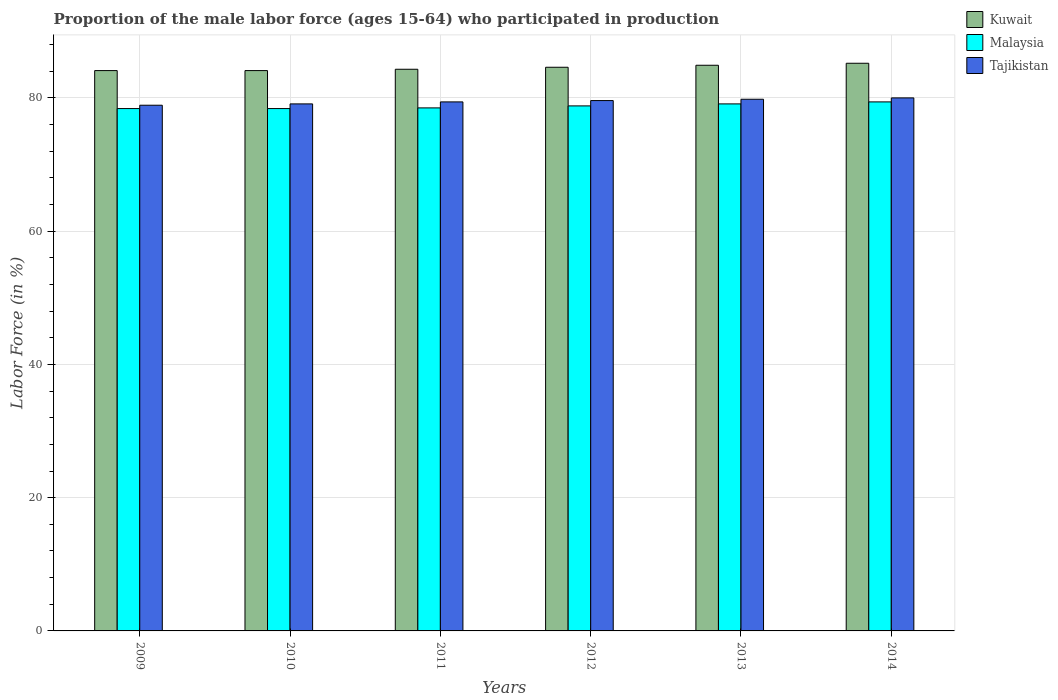How many bars are there on the 6th tick from the left?
Give a very brief answer. 3. In how many cases, is the number of bars for a given year not equal to the number of legend labels?
Your answer should be very brief. 0. What is the proportion of the male labor force who participated in production in Tajikistan in 2010?
Make the answer very short. 79.1. Across all years, what is the maximum proportion of the male labor force who participated in production in Tajikistan?
Give a very brief answer. 80. Across all years, what is the minimum proportion of the male labor force who participated in production in Kuwait?
Ensure brevity in your answer.  84.1. In which year was the proportion of the male labor force who participated in production in Kuwait maximum?
Provide a short and direct response. 2014. In which year was the proportion of the male labor force who participated in production in Kuwait minimum?
Provide a short and direct response. 2009. What is the total proportion of the male labor force who participated in production in Malaysia in the graph?
Your answer should be very brief. 472.6. What is the difference between the proportion of the male labor force who participated in production in Malaysia in 2013 and that in 2014?
Make the answer very short. -0.3. What is the difference between the proportion of the male labor force who participated in production in Kuwait in 2012 and the proportion of the male labor force who participated in production in Tajikistan in 2013?
Make the answer very short. 4.8. What is the average proportion of the male labor force who participated in production in Malaysia per year?
Keep it short and to the point. 78.77. In the year 2012, what is the difference between the proportion of the male labor force who participated in production in Malaysia and proportion of the male labor force who participated in production in Kuwait?
Your response must be concise. -5.8. What is the ratio of the proportion of the male labor force who participated in production in Tajikistan in 2010 to that in 2014?
Make the answer very short. 0.99. Is the proportion of the male labor force who participated in production in Malaysia in 2009 less than that in 2012?
Your answer should be compact. Yes. What is the difference between the highest and the second highest proportion of the male labor force who participated in production in Tajikistan?
Provide a short and direct response. 0.2. What is the difference between the highest and the lowest proportion of the male labor force who participated in production in Kuwait?
Your answer should be very brief. 1.1. In how many years, is the proportion of the male labor force who participated in production in Tajikistan greater than the average proportion of the male labor force who participated in production in Tajikistan taken over all years?
Make the answer very short. 3. What does the 1st bar from the left in 2009 represents?
Ensure brevity in your answer.  Kuwait. What does the 2nd bar from the right in 2011 represents?
Provide a short and direct response. Malaysia. How many bars are there?
Your answer should be very brief. 18. How many years are there in the graph?
Provide a succinct answer. 6. What is the difference between two consecutive major ticks on the Y-axis?
Ensure brevity in your answer.  20. Does the graph contain any zero values?
Ensure brevity in your answer.  No. Does the graph contain grids?
Make the answer very short. Yes. Where does the legend appear in the graph?
Provide a succinct answer. Top right. How many legend labels are there?
Your response must be concise. 3. What is the title of the graph?
Offer a terse response. Proportion of the male labor force (ages 15-64) who participated in production. What is the Labor Force (in %) in Kuwait in 2009?
Give a very brief answer. 84.1. What is the Labor Force (in %) in Malaysia in 2009?
Provide a succinct answer. 78.4. What is the Labor Force (in %) in Tajikistan in 2009?
Provide a short and direct response. 78.9. What is the Labor Force (in %) in Kuwait in 2010?
Give a very brief answer. 84.1. What is the Labor Force (in %) in Malaysia in 2010?
Offer a terse response. 78.4. What is the Labor Force (in %) of Tajikistan in 2010?
Give a very brief answer. 79.1. What is the Labor Force (in %) in Kuwait in 2011?
Keep it short and to the point. 84.3. What is the Labor Force (in %) of Malaysia in 2011?
Give a very brief answer. 78.5. What is the Labor Force (in %) in Tajikistan in 2011?
Give a very brief answer. 79.4. What is the Labor Force (in %) in Kuwait in 2012?
Your answer should be very brief. 84.6. What is the Labor Force (in %) of Malaysia in 2012?
Your response must be concise. 78.8. What is the Labor Force (in %) of Tajikistan in 2012?
Your answer should be compact. 79.6. What is the Labor Force (in %) of Kuwait in 2013?
Keep it short and to the point. 84.9. What is the Labor Force (in %) of Malaysia in 2013?
Keep it short and to the point. 79.1. What is the Labor Force (in %) of Tajikistan in 2013?
Your answer should be very brief. 79.8. What is the Labor Force (in %) in Kuwait in 2014?
Your answer should be compact. 85.2. What is the Labor Force (in %) in Malaysia in 2014?
Provide a succinct answer. 79.4. What is the Labor Force (in %) in Tajikistan in 2014?
Provide a short and direct response. 80. Across all years, what is the maximum Labor Force (in %) in Kuwait?
Your answer should be compact. 85.2. Across all years, what is the maximum Labor Force (in %) of Malaysia?
Your answer should be very brief. 79.4. Across all years, what is the minimum Labor Force (in %) in Kuwait?
Provide a short and direct response. 84.1. Across all years, what is the minimum Labor Force (in %) of Malaysia?
Your answer should be very brief. 78.4. Across all years, what is the minimum Labor Force (in %) of Tajikistan?
Keep it short and to the point. 78.9. What is the total Labor Force (in %) in Kuwait in the graph?
Your answer should be very brief. 507.2. What is the total Labor Force (in %) in Malaysia in the graph?
Offer a very short reply. 472.6. What is the total Labor Force (in %) in Tajikistan in the graph?
Provide a short and direct response. 476.8. What is the difference between the Labor Force (in %) in Malaysia in 2009 and that in 2010?
Provide a succinct answer. 0. What is the difference between the Labor Force (in %) of Tajikistan in 2009 and that in 2010?
Your answer should be compact. -0.2. What is the difference between the Labor Force (in %) of Tajikistan in 2009 and that in 2011?
Ensure brevity in your answer.  -0.5. What is the difference between the Labor Force (in %) of Kuwait in 2009 and that in 2012?
Offer a terse response. -0.5. What is the difference between the Labor Force (in %) in Tajikistan in 2009 and that in 2012?
Offer a very short reply. -0.7. What is the difference between the Labor Force (in %) of Kuwait in 2009 and that in 2013?
Offer a very short reply. -0.8. What is the difference between the Labor Force (in %) of Malaysia in 2009 and that in 2013?
Keep it short and to the point. -0.7. What is the difference between the Labor Force (in %) in Malaysia in 2009 and that in 2014?
Provide a succinct answer. -1. What is the difference between the Labor Force (in %) in Malaysia in 2010 and that in 2011?
Ensure brevity in your answer.  -0.1. What is the difference between the Labor Force (in %) of Tajikistan in 2010 and that in 2011?
Ensure brevity in your answer.  -0.3. What is the difference between the Labor Force (in %) of Kuwait in 2010 and that in 2012?
Keep it short and to the point. -0.5. What is the difference between the Labor Force (in %) in Tajikistan in 2010 and that in 2012?
Keep it short and to the point. -0.5. What is the difference between the Labor Force (in %) in Kuwait in 2010 and that in 2013?
Provide a succinct answer. -0.8. What is the difference between the Labor Force (in %) in Malaysia in 2010 and that in 2013?
Keep it short and to the point. -0.7. What is the difference between the Labor Force (in %) of Tajikistan in 2010 and that in 2013?
Offer a terse response. -0.7. What is the difference between the Labor Force (in %) in Kuwait in 2010 and that in 2014?
Ensure brevity in your answer.  -1.1. What is the difference between the Labor Force (in %) in Malaysia in 2010 and that in 2014?
Your answer should be very brief. -1. What is the difference between the Labor Force (in %) in Kuwait in 2011 and that in 2012?
Ensure brevity in your answer.  -0.3. What is the difference between the Labor Force (in %) of Tajikistan in 2011 and that in 2012?
Give a very brief answer. -0.2. What is the difference between the Labor Force (in %) in Kuwait in 2011 and that in 2013?
Make the answer very short. -0.6. What is the difference between the Labor Force (in %) of Malaysia in 2011 and that in 2013?
Your answer should be compact. -0.6. What is the difference between the Labor Force (in %) of Tajikistan in 2011 and that in 2013?
Make the answer very short. -0.4. What is the difference between the Labor Force (in %) of Kuwait in 2011 and that in 2014?
Ensure brevity in your answer.  -0.9. What is the difference between the Labor Force (in %) in Tajikistan in 2011 and that in 2014?
Make the answer very short. -0.6. What is the difference between the Labor Force (in %) in Malaysia in 2012 and that in 2013?
Make the answer very short. -0.3. What is the difference between the Labor Force (in %) of Kuwait in 2012 and that in 2014?
Your response must be concise. -0.6. What is the difference between the Labor Force (in %) of Tajikistan in 2012 and that in 2014?
Keep it short and to the point. -0.4. What is the difference between the Labor Force (in %) of Malaysia in 2009 and the Labor Force (in %) of Tajikistan in 2010?
Keep it short and to the point. -0.7. What is the difference between the Labor Force (in %) in Kuwait in 2009 and the Labor Force (in %) in Tajikistan in 2011?
Ensure brevity in your answer.  4.7. What is the difference between the Labor Force (in %) in Kuwait in 2009 and the Labor Force (in %) in Malaysia in 2012?
Ensure brevity in your answer.  5.3. What is the difference between the Labor Force (in %) in Kuwait in 2009 and the Labor Force (in %) in Tajikistan in 2012?
Provide a short and direct response. 4.5. What is the difference between the Labor Force (in %) of Malaysia in 2009 and the Labor Force (in %) of Tajikistan in 2012?
Make the answer very short. -1.2. What is the difference between the Labor Force (in %) in Kuwait in 2009 and the Labor Force (in %) in Tajikistan in 2013?
Your answer should be very brief. 4.3. What is the difference between the Labor Force (in %) in Malaysia in 2009 and the Labor Force (in %) in Tajikistan in 2013?
Give a very brief answer. -1.4. What is the difference between the Labor Force (in %) in Kuwait in 2009 and the Labor Force (in %) in Tajikistan in 2014?
Make the answer very short. 4.1. What is the difference between the Labor Force (in %) of Kuwait in 2010 and the Labor Force (in %) of Malaysia in 2011?
Keep it short and to the point. 5.6. What is the difference between the Labor Force (in %) of Kuwait in 2010 and the Labor Force (in %) of Malaysia in 2012?
Your answer should be very brief. 5.3. What is the difference between the Labor Force (in %) in Kuwait in 2010 and the Labor Force (in %) in Tajikistan in 2012?
Your answer should be very brief. 4.5. What is the difference between the Labor Force (in %) in Malaysia in 2010 and the Labor Force (in %) in Tajikistan in 2012?
Give a very brief answer. -1.2. What is the difference between the Labor Force (in %) in Kuwait in 2011 and the Labor Force (in %) in Tajikistan in 2013?
Make the answer very short. 4.5. What is the difference between the Labor Force (in %) of Kuwait in 2011 and the Labor Force (in %) of Malaysia in 2014?
Your answer should be very brief. 4.9. What is the difference between the Labor Force (in %) of Kuwait in 2012 and the Labor Force (in %) of Malaysia in 2013?
Offer a very short reply. 5.5. What is the difference between the Labor Force (in %) in Malaysia in 2012 and the Labor Force (in %) in Tajikistan in 2014?
Make the answer very short. -1.2. What is the difference between the Labor Force (in %) in Kuwait in 2013 and the Labor Force (in %) in Malaysia in 2014?
Give a very brief answer. 5.5. What is the difference between the Labor Force (in %) of Kuwait in 2013 and the Labor Force (in %) of Tajikistan in 2014?
Provide a succinct answer. 4.9. What is the difference between the Labor Force (in %) of Malaysia in 2013 and the Labor Force (in %) of Tajikistan in 2014?
Provide a succinct answer. -0.9. What is the average Labor Force (in %) in Kuwait per year?
Offer a terse response. 84.53. What is the average Labor Force (in %) of Malaysia per year?
Your answer should be very brief. 78.77. What is the average Labor Force (in %) in Tajikistan per year?
Offer a very short reply. 79.47. In the year 2009, what is the difference between the Labor Force (in %) of Malaysia and Labor Force (in %) of Tajikistan?
Offer a terse response. -0.5. In the year 2010, what is the difference between the Labor Force (in %) of Kuwait and Labor Force (in %) of Tajikistan?
Give a very brief answer. 5. In the year 2010, what is the difference between the Labor Force (in %) in Malaysia and Labor Force (in %) in Tajikistan?
Keep it short and to the point. -0.7. In the year 2012, what is the difference between the Labor Force (in %) of Kuwait and Labor Force (in %) of Malaysia?
Your response must be concise. 5.8. In the year 2012, what is the difference between the Labor Force (in %) in Kuwait and Labor Force (in %) in Tajikistan?
Your answer should be very brief. 5. In the year 2012, what is the difference between the Labor Force (in %) of Malaysia and Labor Force (in %) of Tajikistan?
Keep it short and to the point. -0.8. What is the ratio of the Labor Force (in %) in Kuwait in 2009 to that in 2010?
Make the answer very short. 1. What is the ratio of the Labor Force (in %) in Tajikistan in 2009 to that in 2010?
Make the answer very short. 1. What is the ratio of the Labor Force (in %) in Tajikistan in 2009 to that in 2011?
Your answer should be very brief. 0.99. What is the ratio of the Labor Force (in %) in Kuwait in 2009 to that in 2013?
Offer a very short reply. 0.99. What is the ratio of the Labor Force (in %) in Malaysia in 2009 to that in 2013?
Your answer should be compact. 0.99. What is the ratio of the Labor Force (in %) of Tajikistan in 2009 to that in 2013?
Your answer should be compact. 0.99. What is the ratio of the Labor Force (in %) in Kuwait in 2009 to that in 2014?
Your response must be concise. 0.99. What is the ratio of the Labor Force (in %) in Malaysia in 2009 to that in 2014?
Offer a very short reply. 0.99. What is the ratio of the Labor Force (in %) of Tajikistan in 2009 to that in 2014?
Offer a terse response. 0.99. What is the ratio of the Labor Force (in %) of Tajikistan in 2010 to that in 2011?
Provide a short and direct response. 1. What is the ratio of the Labor Force (in %) in Malaysia in 2010 to that in 2012?
Provide a succinct answer. 0.99. What is the ratio of the Labor Force (in %) of Kuwait in 2010 to that in 2013?
Make the answer very short. 0.99. What is the ratio of the Labor Force (in %) in Kuwait in 2010 to that in 2014?
Offer a terse response. 0.99. What is the ratio of the Labor Force (in %) in Malaysia in 2010 to that in 2014?
Ensure brevity in your answer.  0.99. What is the ratio of the Labor Force (in %) in Tajikistan in 2010 to that in 2014?
Offer a very short reply. 0.99. What is the ratio of the Labor Force (in %) in Malaysia in 2011 to that in 2012?
Provide a succinct answer. 1. What is the ratio of the Labor Force (in %) in Kuwait in 2011 to that in 2013?
Keep it short and to the point. 0.99. What is the ratio of the Labor Force (in %) in Malaysia in 2011 to that in 2013?
Your answer should be very brief. 0.99. What is the ratio of the Labor Force (in %) of Kuwait in 2011 to that in 2014?
Offer a very short reply. 0.99. What is the ratio of the Labor Force (in %) in Malaysia in 2011 to that in 2014?
Your response must be concise. 0.99. What is the ratio of the Labor Force (in %) in Kuwait in 2012 to that in 2013?
Provide a short and direct response. 1. What is the ratio of the Labor Force (in %) in Tajikistan in 2012 to that in 2013?
Your answer should be compact. 1. What is the ratio of the Labor Force (in %) in Malaysia in 2012 to that in 2014?
Give a very brief answer. 0.99. What is the ratio of the Labor Force (in %) of Tajikistan in 2012 to that in 2014?
Your answer should be very brief. 0.99. What is the ratio of the Labor Force (in %) in Kuwait in 2013 to that in 2014?
Your response must be concise. 1. What is the ratio of the Labor Force (in %) in Malaysia in 2013 to that in 2014?
Provide a succinct answer. 1. What is the difference between the highest and the second highest Labor Force (in %) in Malaysia?
Offer a very short reply. 0.3. What is the difference between the highest and the second highest Labor Force (in %) of Tajikistan?
Offer a terse response. 0.2. 